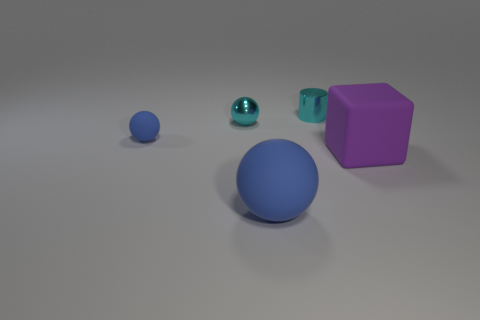Add 1 big purple matte objects. How many objects exist? 6 Subtract all cylinders. How many objects are left? 4 Subtract all purple cubes. Subtract all red metal cubes. How many objects are left? 4 Add 3 small blue matte things. How many small blue matte things are left? 4 Add 5 big green shiny cylinders. How many big green shiny cylinders exist? 5 Subtract 1 purple blocks. How many objects are left? 4 